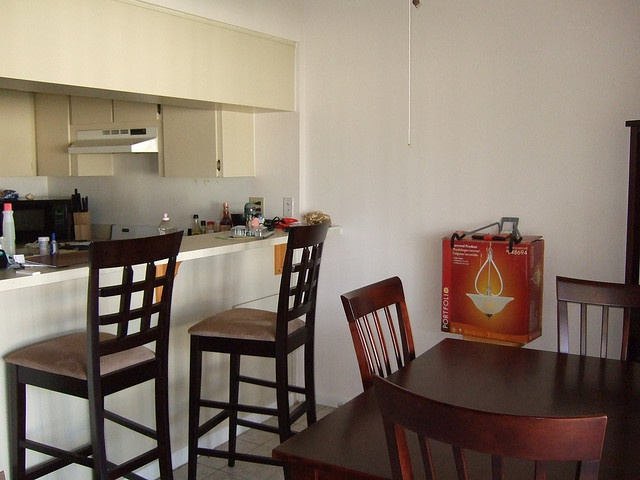Describe the objects in this image and their specific colors. I can see chair in tan, black, darkgray, gray, and maroon tones, dining table in tan, black, and gray tones, chair in tan, black, gray, darkgray, and maroon tones, chair in tan, black, maroon, and brown tones, and chair in tan, gray, and black tones in this image. 